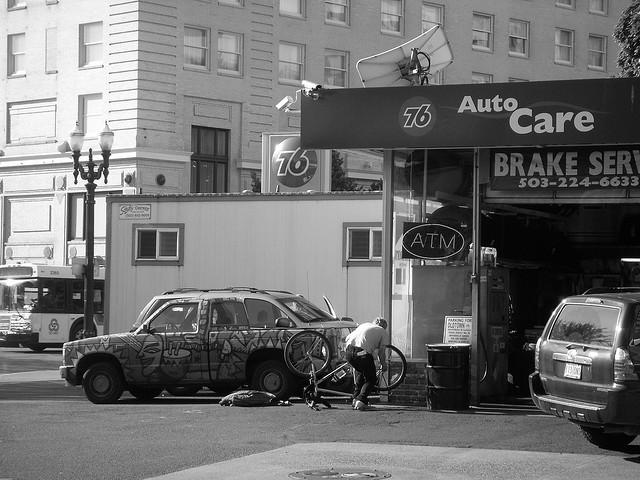Where is the cars at?
Keep it brief. Shop. What kind of bike is in front of this building?
Short answer required. Bicycle. What is the place of business in the picture?
Answer briefly. Auto care. What city was the photo taken in?
Give a very brief answer. Detroit. Is there a satellite in the photo?
Short answer required. Yes. Is this a Madrid city tour bus?
Short answer required. No. What is the ad on the wall for?
Concise answer only. Auto care. Is the sign in English?
Short answer required. Yes. 